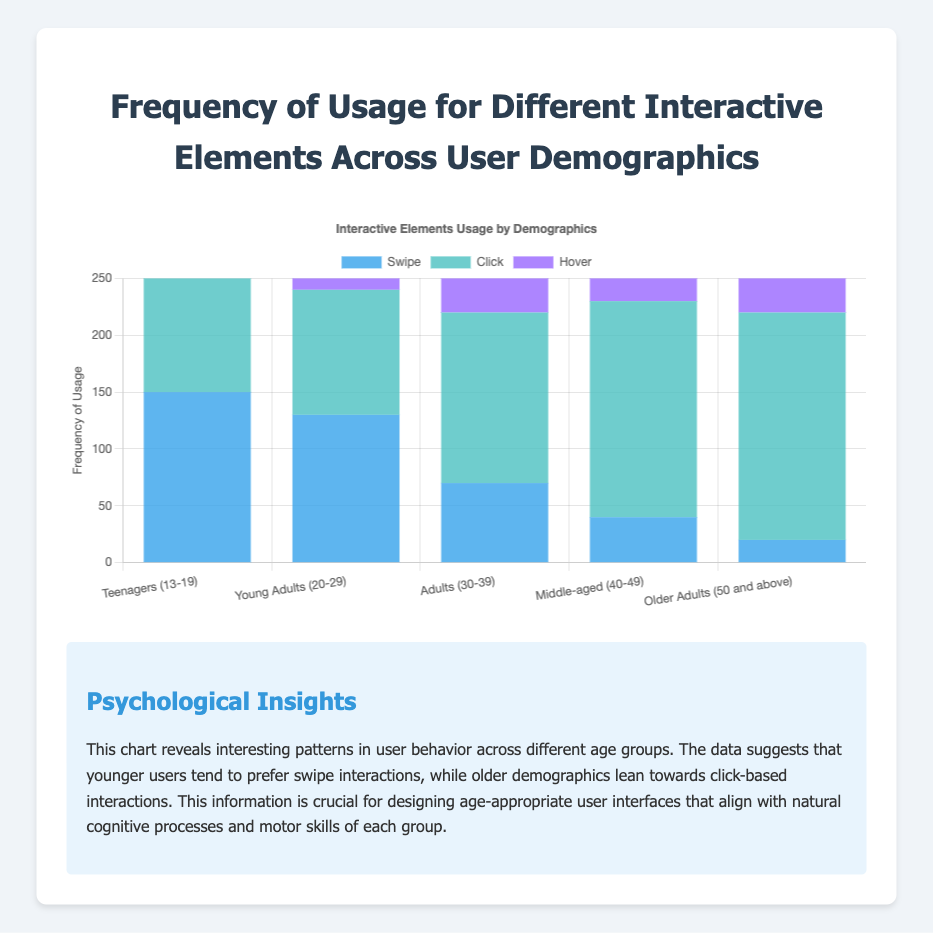How many more times do Young Adults (20-29) use swipe than Older Adults (50 and above)? Young Adults (20-29) have 130 swipe uses, while Older Adults (50 and above) have 20 swipe uses. The difference is 130 - 20 = 110
Answer: 110 Which demographic has the highest frequency of click usage? By examining the bar heights for click usage across demographics, Middle-aged (40-49) and Older Adults (50 and above) both demonstrate the highest usage at 200
Answer: Middle-aged (40-49) and Older Adults (50 and above) What is the total frequency of swipe interactions for all demographics combined? Summing up the swipe frequencies: 150 (Teenagers) + 130 (Young Adults) + 70 (Adults) + 40 (Middle-aged) + 20 (Older Adults). That results in 150 + 130 + 70 + 40 + 20 = 410
Answer: 410 Between which two demographics is the difference in hover usage the most significant? Comparing hover usage, Teenagers (13-19) and Middle-aged (40-49) show hover frequencies of 50 and 100, respectively. The difference is 100 - 50 = 50, which is the largest difference among all pairs
Answer: Teenagers and Middle-aged How does the click usage of Adults (30-39) compare to the swipe usage of the same demographic? Adults (30-39) click frequency is 150, while their swipe frequency is 70. Therefore, Adults click more frequently than they swipe (150 - 70 = 80)
Answer: Adults click more than swipe by 80 What is the average hover frequency across all demographics? Summing up the hover frequencies: 50 (Teenagers) + 60 (Young Adults) + 80 (Adults) + 100 (Middle-aged) + 90 (Older Adults). The average is (50 + 60 + 80 + 100 + 90) / 5 = 76
Answer: 76 Which interaction type is the least used by Middle-aged (40-49) demographic? By examining the bars for the Middle-aged demographic, swipe has the shortest bar with 40, compared to click (190) and hover (100)
Answer: Swipe What is the combined frequency of hover usage for both Adults (30-39) and Older Adults (50 and above)? Summing hover frequencies for Adults (30-39) and Older Adults (50 and above): 80 + 90 = 170
Answer: 170 Across all demographics, which interaction type is used the most frequently? Summing up all interaction type frequencies: Swipe (410), Click (750), and Hover (380). Click, with 750, is the most frequently used interaction
Answer: Click 